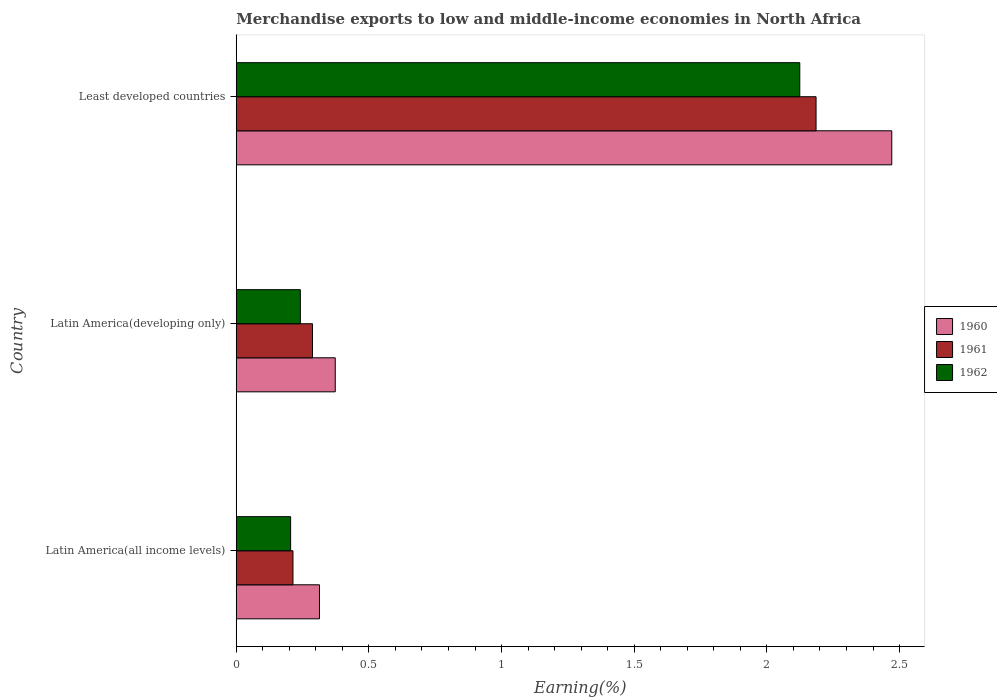How many different coloured bars are there?
Your answer should be very brief. 3. How many groups of bars are there?
Keep it short and to the point. 3. Are the number of bars per tick equal to the number of legend labels?
Give a very brief answer. Yes. Are the number of bars on each tick of the Y-axis equal?
Your answer should be very brief. Yes. How many bars are there on the 3rd tick from the bottom?
Your answer should be very brief. 3. What is the label of the 1st group of bars from the top?
Offer a very short reply. Least developed countries. What is the percentage of amount earned from merchandise exports in 1960 in Latin America(all income levels)?
Keep it short and to the point. 0.31. Across all countries, what is the maximum percentage of amount earned from merchandise exports in 1962?
Provide a short and direct response. 2.12. Across all countries, what is the minimum percentage of amount earned from merchandise exports in 1960?
Your answer should be compact. 0.31. In which country was the percentage of amount earned from merchandise exports in 1961 maximum?
Give a very brief answer. Least developed countries. In which country was the percentage of amount earned from merchandise exports in 1961 minimum?
Your response must be concise. Latin America(all income levels). What is the total percentage of amount earned from merchandise exports in 1960 in the graph?
Offer a very short reply. 3.16. What is the difference between the percentage of amount earned from merchandise exports in 1962 in Latin America(developing only) and that in Least developed countries?
Offer a terse response. -1.88. What is the difference between the percentage of amount earned from merchandise exports in 1961 in Latin America(all income levels) and the percentage of amount earned from merchandise exports in 1962 in Latin America(developing only)?
Provide a short and direct response. -0.03. What is the average percentage of amount earned from merchandise exports in 1961 per country?
Keep it short and to the point. 0.9. What is the difference between the percentage of amount earned from merchandise exports in 1962 and percentage of amount earned from merchandise exports in 1961 in Least developed countries?
Keep it short and to the point. -0.06. What is the ratio of the percentage of amount earned from merchandise exports in 1960 in Latin America(all income levels) to that in Latin America(developing only)?
Offer a very short reply. 0.84. Is the difference between the percentage of amount earned from merchandise exports in 1962 in Latin America(all income levels) and Latin America(developing only) greater than the difference between the percentage of amount earned from merchandise exports in 1961 in Latin America(all income levels) and Latin America(developing only)?
Give a very brief answer. Yes. What is the difference between the highest and the second highest percentage of amount earned from merchandise exports in 1961?
Provide a succinct answer. 1.9. What is the difference between the highest and the lowest percentage of amount earned from merchandise exports in 1961?
Keep it short and to the point. 1.97. In how many countries, is the percentage of amount earned from merchandise exports in 1961 greater than the average percentage of amount earned from merchandise exports in 1961 taken over all countries?
Your answer should be very brief. 1. Is the sum of the percentage of amount earned from merchandise exports in 1962 in Latin America(developing only) and Least developed countries greater than the maximum percentage of amount earned from merchandise exports in 1961 across all countries?
Make the answer very short. Yes. Is it the case that in every country, the sum of the percentage of amount earned from merchandise exports in 1962 and percentage of amount earned from merchandise exports in 1961 is greater than the percentage of amount earned from merchandise exports in 1960?
Offer a terse response. Yes. Are all the bars in the graph horizontal?
Your response must be concise. Yes. How many countries are there in the graph?
Give a very brief answer. 3. What is the difference between two consecutive major ticks on the X-axis?
Your answer should be very brief. 0.5. Where does the legend appear in the graph?
Keep it short and to the point. Center right. How many legend labels are there?
Ensure brevity in your answer.  3. What is the title of the graph?
Keep it short and to the point. Merchandise exports to low and middle-income economies in North Africa. What is the label or title of the X-axis?
Your answer should be very brief. Earning(%). What is the label or title of the Y-axis?
Provide a short and direct response. Country. What is the Earning(%) in 1960 in Latin America(all income levels)?
Offer a terse response. 0.31. What is the Earning(%) of 1961 in Latin America(all income levels)?
Keep it short and to the point. 0.21. What is the Earning(%) in 1962 in Latin America(all income levels)?
Your response must be concise. 0.2. What is the Earning(%) of 1960 in Latin America(developing only)?
Provide a short and direct response. 0.37. What is the Earning(%) in 1961 in Latin America(developing only)?
Your answer should be very brief. 0.29. What is the Earning(%) of 1962 in Latin America(developing only)?
Offer a terse response. 0.24. What is the Earning(%) in 1960 in Least developed countries?
Offer a terse response. 2.47. What is the Earning(%) in 1961 in Least developed countries?
Your response must be concise. 2.19. What is the Earning(%) of 1962 in Least developed countries?
Offer a terse response. 2.12. Across all countries, what is the maximum Earning(%) of 1960?
Provide a succinct answer. 2.47. Across all countries, what is the maximum Earning(%) in 1961?
Offer a very short reply. 2.19. Across all countries, what is the maximum Earning(%) of 1962?
Make the answer very short. 2.12. Across all countries, what is the minimum Earning(%) of 1960?
Your answer should be compact. 0.31. Across all countries, what is the minimum Earning(%) in 1961?
Provide a short and direct response. 0.21. Across all countries, what is the minimum Earning(%) in 1962?
Your response must be concise. 0.2. What is the total Earning(%) in 1960 in the graph?
Make the answer very short. 3.16. What is the total Earning(%) in 1961 in the graph?
Make the answer very short. 2.69. What is the total Earning(%) in 1962 in the graph?
Offer a very short reply. 2.57. What is the difference between the Earning(%) in 1960 in Latin America(all income levels) and that in Latin America(developing only)?
Make the answer very short. -0.06. What is the difference between the Earning(%) of 1961 in Latin America(all income levels) and that in Latin America(developing only)?
Give a very brief answer. -0.07. What is the difference between the Earning(%) of 1962 in Latin America(all income levels) and that in Latin America(developing only)?
Provide a succinct answer. -0.04. What is the difference between the Earning(%) in 1960 in Latin America(all income levels) and that in Least developed countries?
Offer a very short reply. -2.16. What is the difference between the Earning(%) in 1961 in Latin America(all income levels) and that in Least developed countries?
Provide a succinct answer. -1.97. What is the difference between the Earning(%) in 1962 in Latin America(all income levels) and that in Least developed countries?
Your answer should be very brief. -1.92. What is the difference between the Earning(%) of 1960 in Latin America(developing only) and that in Least developed countries?
Ensure brevity in your answer.  -2.1. What is the difference between the Earning(%) in 1961 in Latin America(developing only) and that in Least developed countries?
Offer a very short reply. -1.9. What is the difference between the Earning(%) in 1962 in Latin America(developing only) and that in Least developed countries?
Make the answer very short. -1.88. What is the difference between the Earning(%) of 1960 in Latin America(all income levels) and the Earning(%) of 1961 in Latin America(developing only)?
Provide a succinct answer. 0.03. What is the difference between the Earning(%) of 1960 in Latin America(all income levels) and the Earning(%) of 1962 in Latin America(developing only)?
Offer a terse response. 0.07. What is the difference between the Earning(%) in 1961 in Latin America(all income levels) and the Earning(%) in 1962 in Latin America(developing only)?
Ensure brevity in your answer.  -0.03. What is the difference between the Earning(%) in 1960 in Latin America(all income levels) and the Earning(%) in 1961 in Least developed countries?
Offer a terse response. -1.87. What is the difference between the Earning(%) of 1960 in Latin America(all income levels) and the Earning(%) of 1962 in Least developed countries?
Make the answer very short. -1.81. What is the difference between the Earning(%) in 1961 in Latin America(all income levels) and the Earning(%) in 1962 in Least developed countries?
Give a very brief answer. -1.91. What is the difference between the Earning(%) in 1960 in Latin America(developing only) and the Earning(%) in 1961 in Least developed countries?
Make the answer very short. -1.81. What is the difference between the Earning(%) in 1960 in Latin America(developing only) and the Earning(%) in 1962 in Least developed countries?
Your response must be concise. -1.75. What is the difference between the Earning(%) in 1961 in Latin America(developing only) and the Earning(%) in 1962 in Least developed countries?
Provide a short and direct response. -1.84. What is the average Earning(%) in 1960 per country?
Your response must be concise. 1.05. What is the average Earning(%) in 1961 per country?
Give a very brief answer. 0.9. What is the average Earning(%) in 1962 per country?
Provide a short and direct response. 0.86. What is the difference between the Earning(%) in 1960 and Earning(%) in 1961 in Latin America(all income levels)?
Make the answer very short. 0.1. What is the difference between the Earning(%) of 1960 and Earning(%) of 1962 in Latin America(all income levels)?
Your answer should be very brief. 0.11. What is the difference between the Earning(%) of 1961 and Earning(%) of 1962 in Latin America(all income levels)?
Ensure brevity in your answer.  0.01. What is the difference between the Earning(%) of 1960 and Earning(%) of 1961 in Latin America(developing only)?
Keep it short and to the point. 0.09. What is the difference between the Earning(%) in 1960 and Earning(%) in 1962 in Latin America(developing only)?
Make the answer very short. 0.13. What is the difference between the Earning(%) of 1961 and Earning(%) of 1962 in Latin America(developing only)?
Make the answer very short. 0.05. What is the difference between the Earning(%) in 1960 and Earning(%) in 1961 in Least developed countries?
Offer a very short reply. 0.29. What is the difference between the Earning(%) in 1960 and Earning(%) in 1962 in Least developed countries?
Offer a terse response. 0.35. What is the difference between the Earning(%) in 1961 and Earning(%) in 1962 in Least developed countries?
Your response must be concise. 0.06. What is the ratio of the Earning(%) in 1960 in Latin America(all income levels) to that in Latin America(developing only)?
Your answer should be very brief. 0.84. What is the ratio of the Earning(%) of 1961 in Latin America(all income levels) to that in Latin America(developing only)?
Your response must be concise. 0.74. What is the ratio of the Earning(%) of 1962 in Latin America(all income levels) to that in Latin America(developing only)?
Provide a succinct answer. 0.85. What is the ratio of the Earning(%) of 1960 in Latin America(all income levels) to that in Least developed countries?
Your answer should be very brief. 0.13. What is the ratio of the Earning(%) in 1961 in Latin America(all income levels) to that in Least developed countries?
Provide a succinct answer. 0.1. What is the ratio of the Earning(%) in 1962 in Latin America(all income levels) to that in Least developed countries?
Your response must be concise. 0.1. What is the ratio of the Earning(%) in 1960 in Latin America(developing only) to that in Least developed countries?
Provide a short and direct response. 0.15. What is the ratio of the Earning(%) of 1961 in Latin America(developing only) to that in Least developed countries?
Keep it short and to the point. 0.13. What is the ratio of the Earning(%) of 1962 in Latin America(developing only) to that in Least developed countries?
Give a very brief answer. 0.11. What is the difference between the highest and the second highest Earning(%) of 1960?
Offer a terse response. 2.1. What is the difference between the highest and the second highest Earning(%) in 1961?
Give a very brief answer. 1.9. What is the difference between the highest and the second highest Earning(%) of 1962?
Keep it short and to the point. 1.88. What is the difference between the highest and the lowest Earning(%) in 1960?
Make the answer very short. 2.16. What is the difference between the highest and the lowest Earning(%) of 1961?
Your answer should be compact. 1.97. What is the difference between the highest and the lowest Earning(%) of 1962?
Provide a succinct answer. 1.92. 